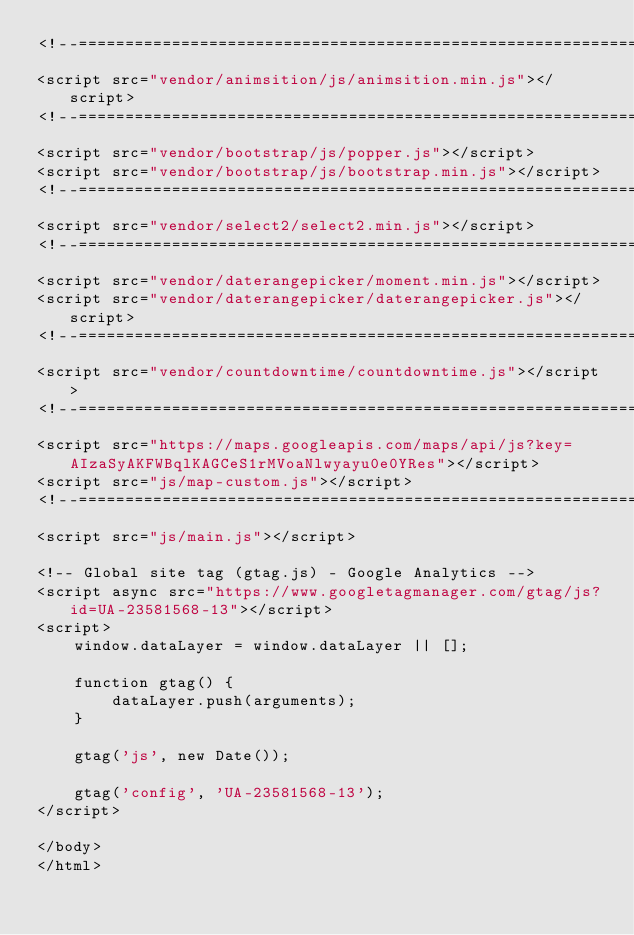Convert code to text. <code><loc_0><loc_0><loc_500><loc_500><_PHP_><!--===============================================================================================-->
<script src="vendor/animsition/js/animsition.min.js"></script>
<!--===============================================================================================-->
<script src="vendor/bootstrap/js/popper.js"></script>
<script src="vendor/bootstrap/js/bootstrap.min.js"></script>
<!--===============================================================================================-->
<script src="vendor/select2/select2.min.js"></script>
<!--===============================================================================================-->
<script src="vendor/daterangepicker/moment.min.js"></script>
<script src="vendor/daterangepicker/daterangepicker.js"></script>
<!--===============================================================================================-->
<script src="vendor/countdowntime/countdowntime.js"></script>
<!--===============================================================================================-->
<script src="https://maps.googleapis.com/maps/api/js?key=AIzaSyAKFWBqlKAGCeS1rMVoaNlwyayu0e0YRes"></script>
<script src="js/map-custom.js"></script>
<!--===============================================================================================-->
<script src="js/main.js"></script>

<!-- Global site tag (gtag.js) - Google Analytics -->
<script async src="https://www.googletagmanager.com/gtag/js?id=UA-23581568-13"></script>
<script>
    window.dataLayer = window.dataLayer || [];

    function gtag() {
        dataLayer.push(arguments);
    }

    gtag('js', new Date());

    gtag('config', 'UA-23581568-13');
</script>

</body>
</html>
</code> 